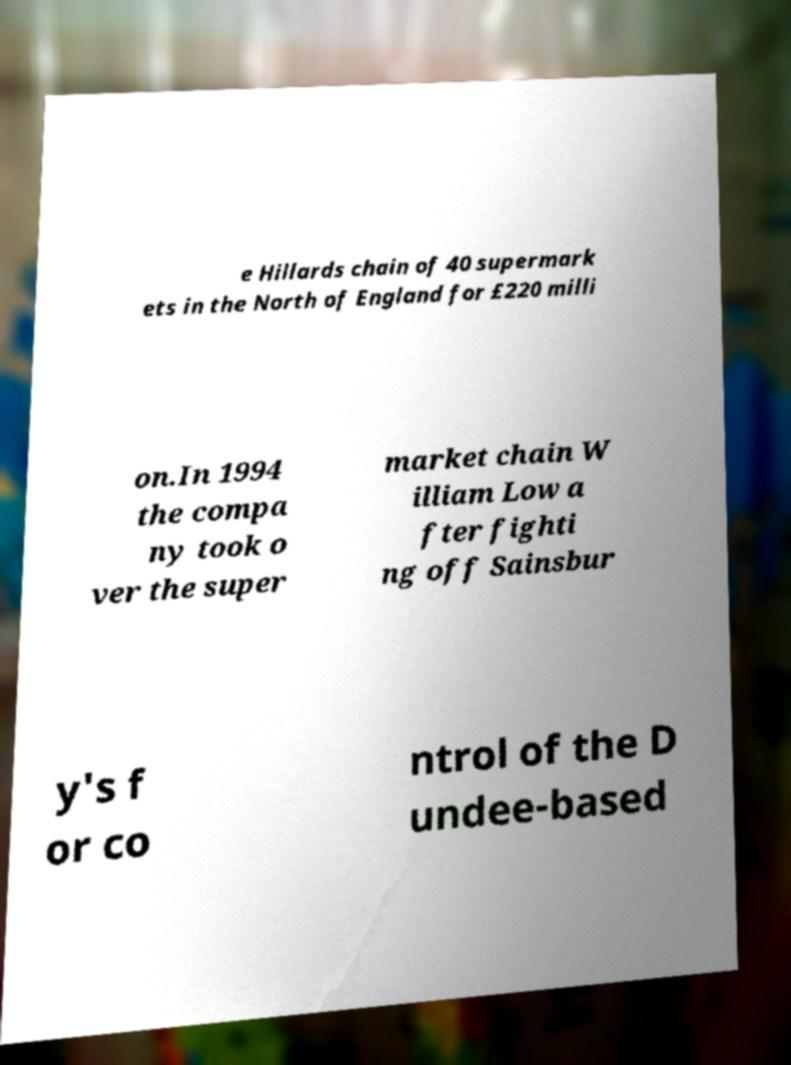What messages or text are displayed in this image? I need them in a readable, typed format. e Hillards chain of 40 supermark ets in the North of England for £220 milli on.In 1994 the compa ny took o ver the super market chain W illiam Low a fter fighti ng off Sainsbur y's f or co ntrol of the D undee-based 